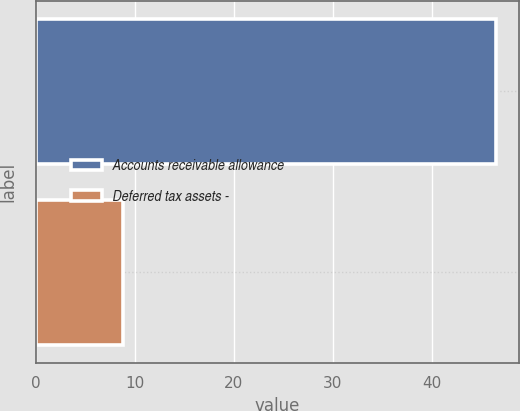Convert chart. <chart><loc_0><loc_0><loc_500><loc_500><bar_chart><fcel>Accounts receivable allowance<fcel>Deferred tax assets -<nl><fcel>46.5<fcel>8.8<nl></chart> 